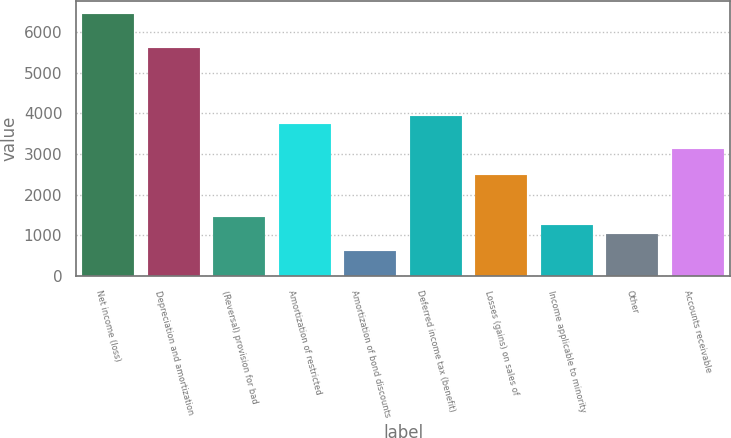Convert chart. <chart><loc_0><loc_0><loc_500><loc_500><bar_chart><fcel>Net income (loss)<fcel>Depreciation and amortization<fcel>(Reversal) provision for bad<fcel>Amortization of restricted<fcel>Amortization of bond discounts<fcel>Deferred income tax (benefit)<fcel>Losses (gains) on sales of<fcel>Income applicable to minority<fcel>Other<fcel>Accounts receivable<nl><fcel>6429.41<fcel>5600.17<fcel>1453.97<fcel>3734.38<fcel>624.73<fcel>3941.69<fcel>2490.52<fcel>1246.66<fcel>1039.35<fcel>3112.45<nl></chart> 